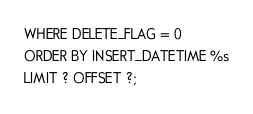<code> <loc_0><loc_0><loc_500><loc_500><_SQL_>WHERE DELETE_FLAG = 0
ORDER BY INSERT_DATETIME %s
LIMIT ? OFFSET ?;
</code> 